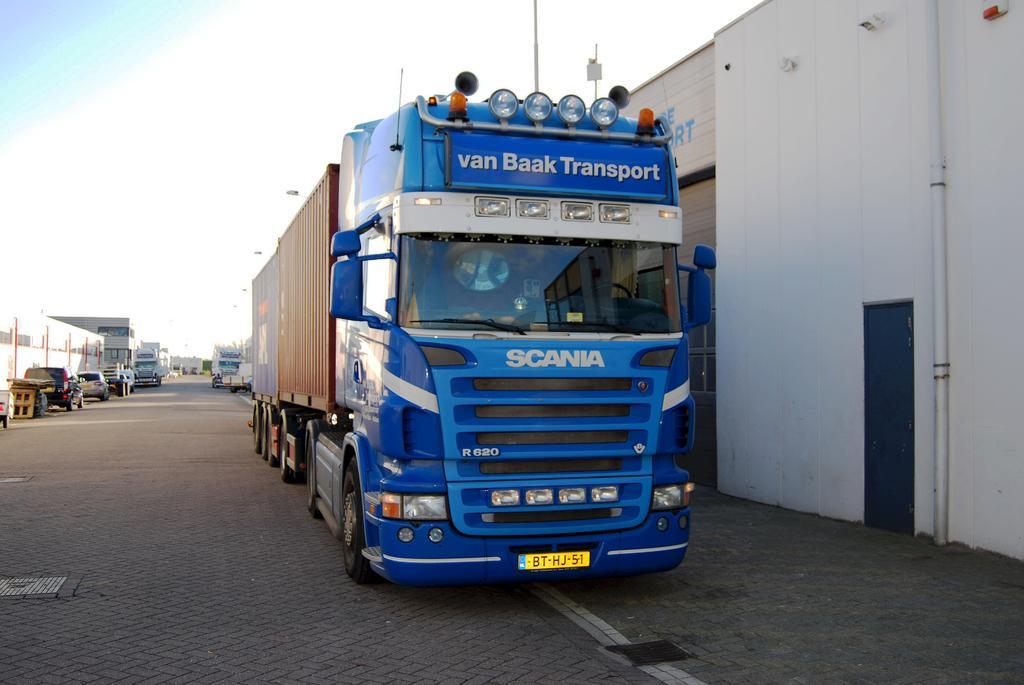How would you summarize this image in a sentence or two? In the center of the image we can see a vehicle with group of lights, text and number plate placed on the ground. In the background, we can see group of vehicles parked on road, wood pieces, buildings, a pipe, door and the sky. 